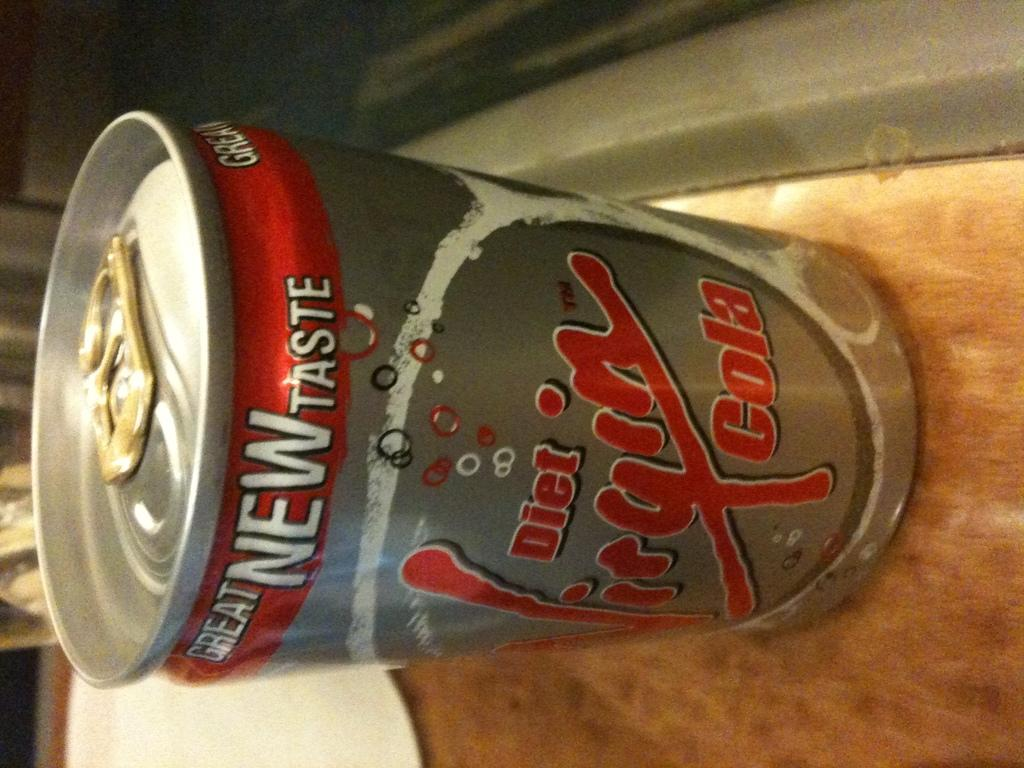Provide a one-sentence caption for the provided image. Brown surface containing diet cola in a silver can. 